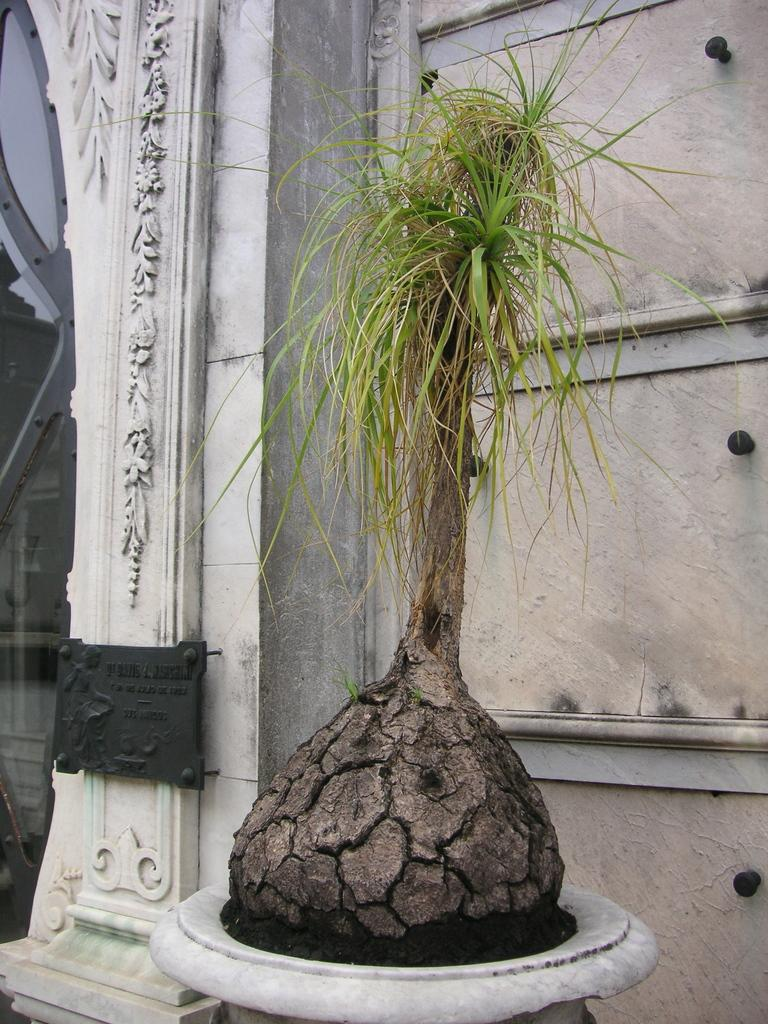What type of plant can be seen in the image? There is a pot plant in the image. What is the background of the image? There is a wall in the image. What is the purpose of the blackboard in the image? The purpose of the blackboard in the image is not specified. Can you describe the unspecified object in the image? Unfortunately, there is not enough information to describe the unspecified object in the image. What type of gate can be seen in the image? There is no gate present in the image. What is the interest rate of the loan mentioned in the image? There is no mention of a loan or interest rate in the image. 